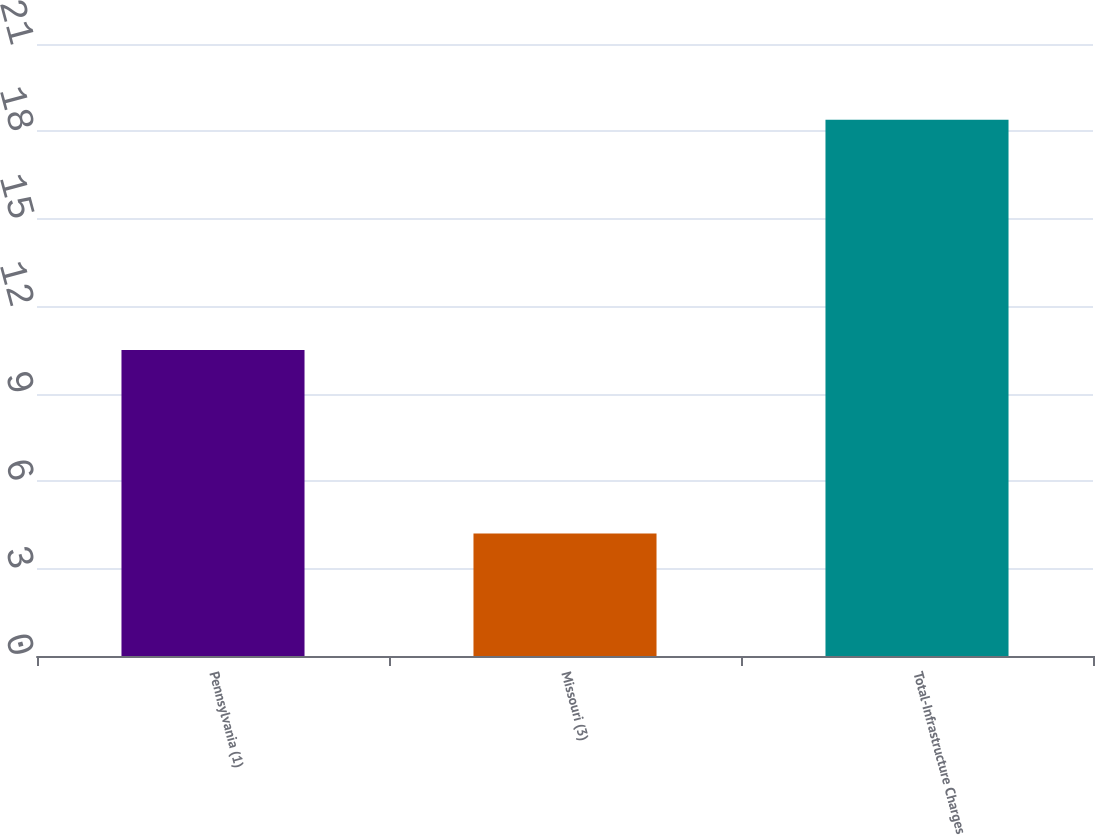Convert chart. <chart><loc_0><loc_0><loc_500><loc_500><bar_chart><fcel>Pennsylvania (1)<fcel>Missouri (3)<fcel>Total-Infrastructure Charges<nl><fcel>10.5<fcel>4.2<fcel>18.4<nl></chart> 